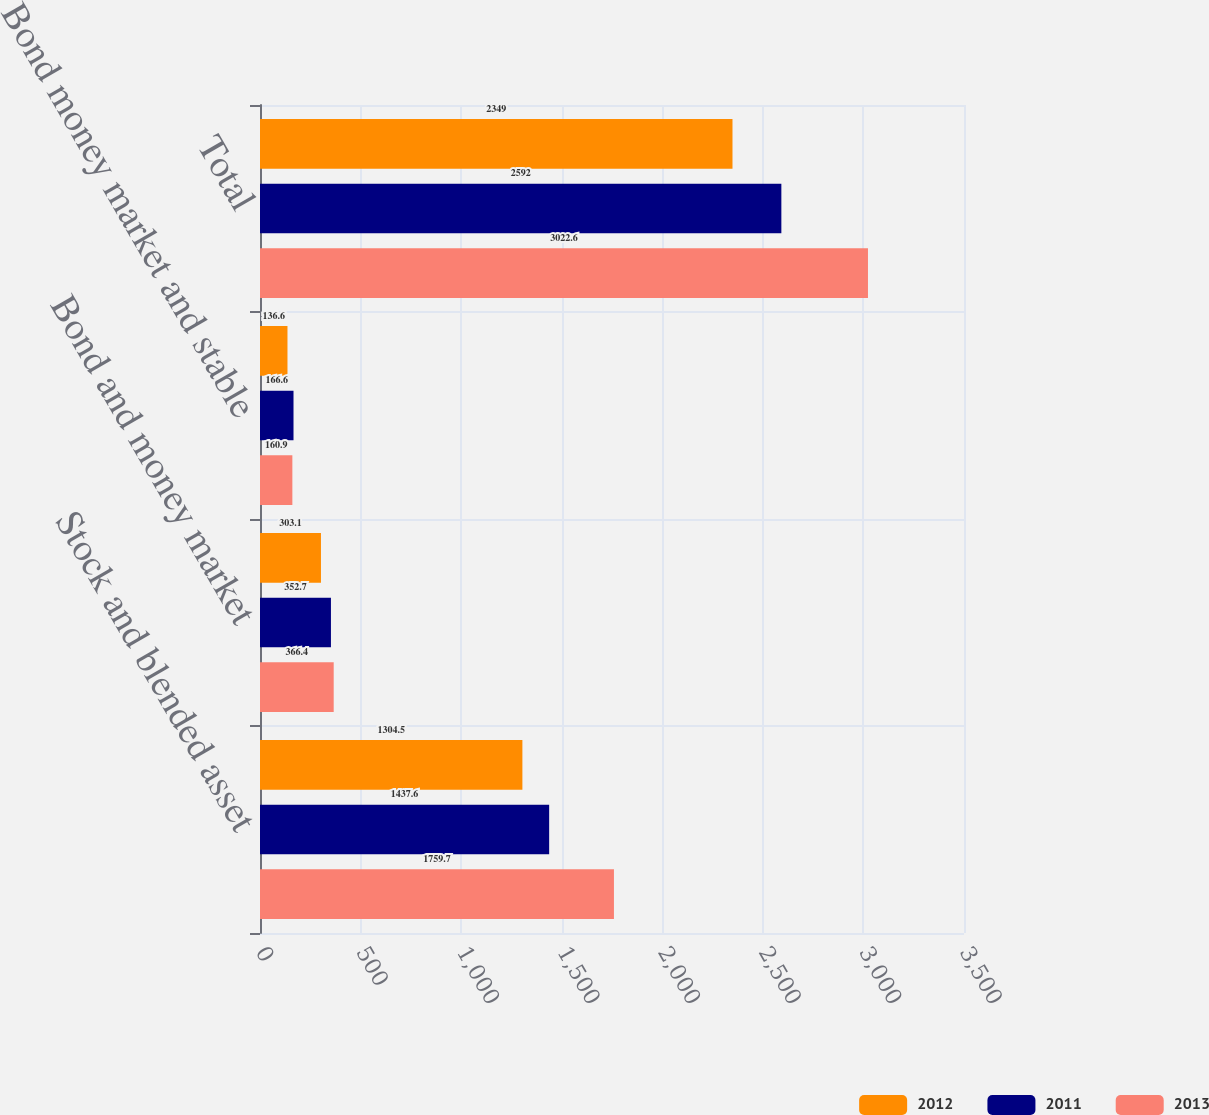Convert chart. <chart><loc_0><loc_0><loc_500><loc_500><stacked_bar_chart><ecel><fcel>Stock and blended asset<fcel>Bond and money market<fcel>Bond money market and stable<fcel>Total<nl><fcel>2012<fcel>1304.5<fcel>303.1<fcel>136.6<fcel>2349<nl><fcel>2011<fcel>1437.6<fcel>352.7<fcel>166.6<fcel>2592<nl><fcel>2013<fcel>1759.7<fcel>366.4<fcel>160.9<fcel>3022.6<nl></chart> 